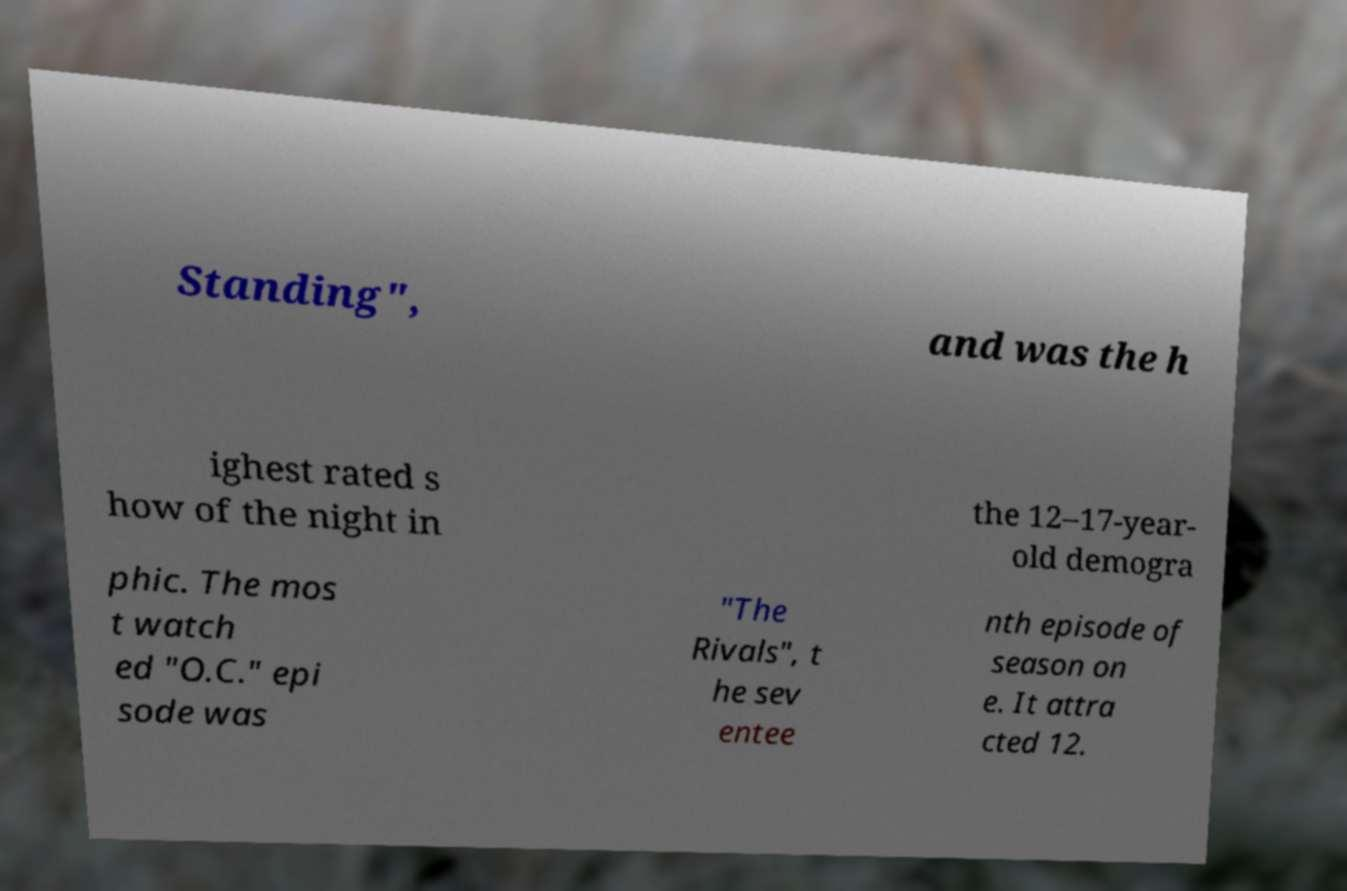I need the written content from this picture converted into text. Can you do that? Standing", and was the h ighest rated s how of the night in the 12–17-year- old demogra phic. The mos t watch ed "O.C." epi sode was "The Rivals", t he sev entee nth episode of season on e. It attra cted 12. 